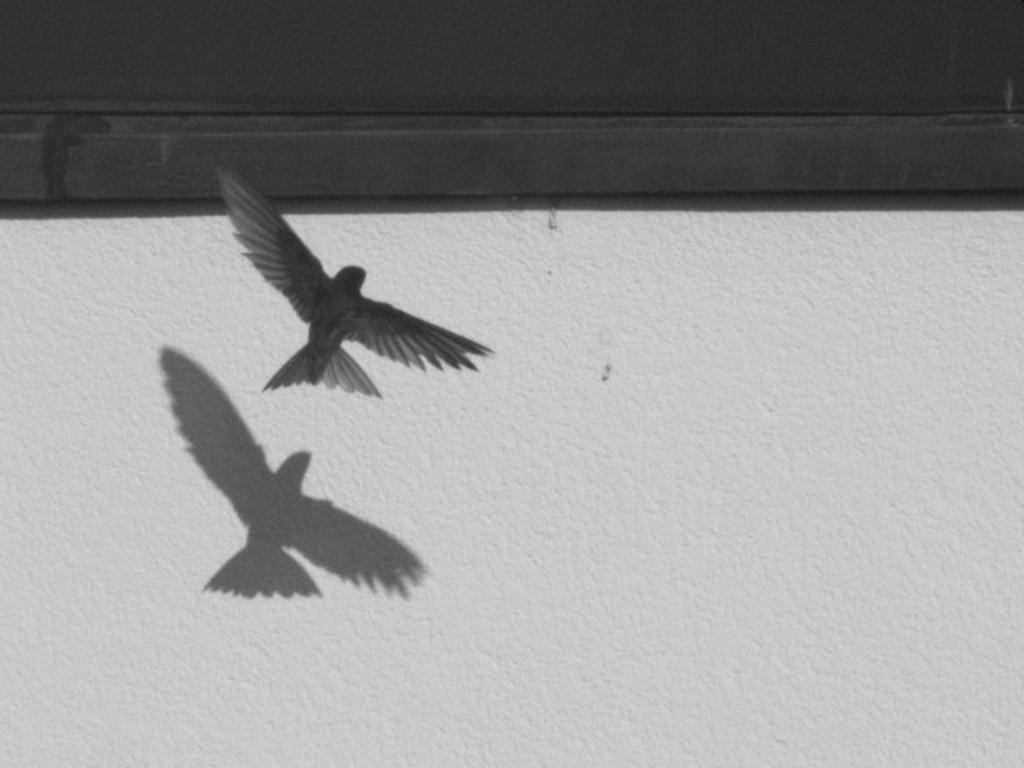What is the bird in the image doing? The bird is flying in the air. What can be observed about the bird's shadow? The bird has a shadow on the wall. What type of material is the wall with the bird's shadow made of? The wall with the bird's shadow is made of wood. What type of marble is visible on the floor in the image? There is no marble visible on the floor in the image. 